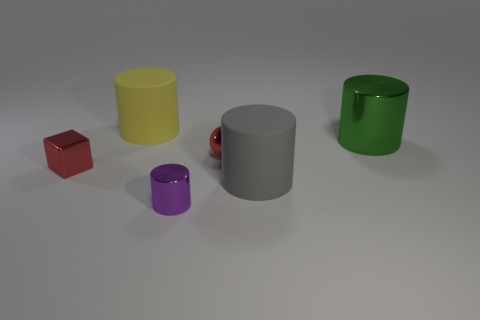Are there more green objects than cyan balls? In the image provided, there is a single green object and no cyan balls, making the number of green objects greater by default. 